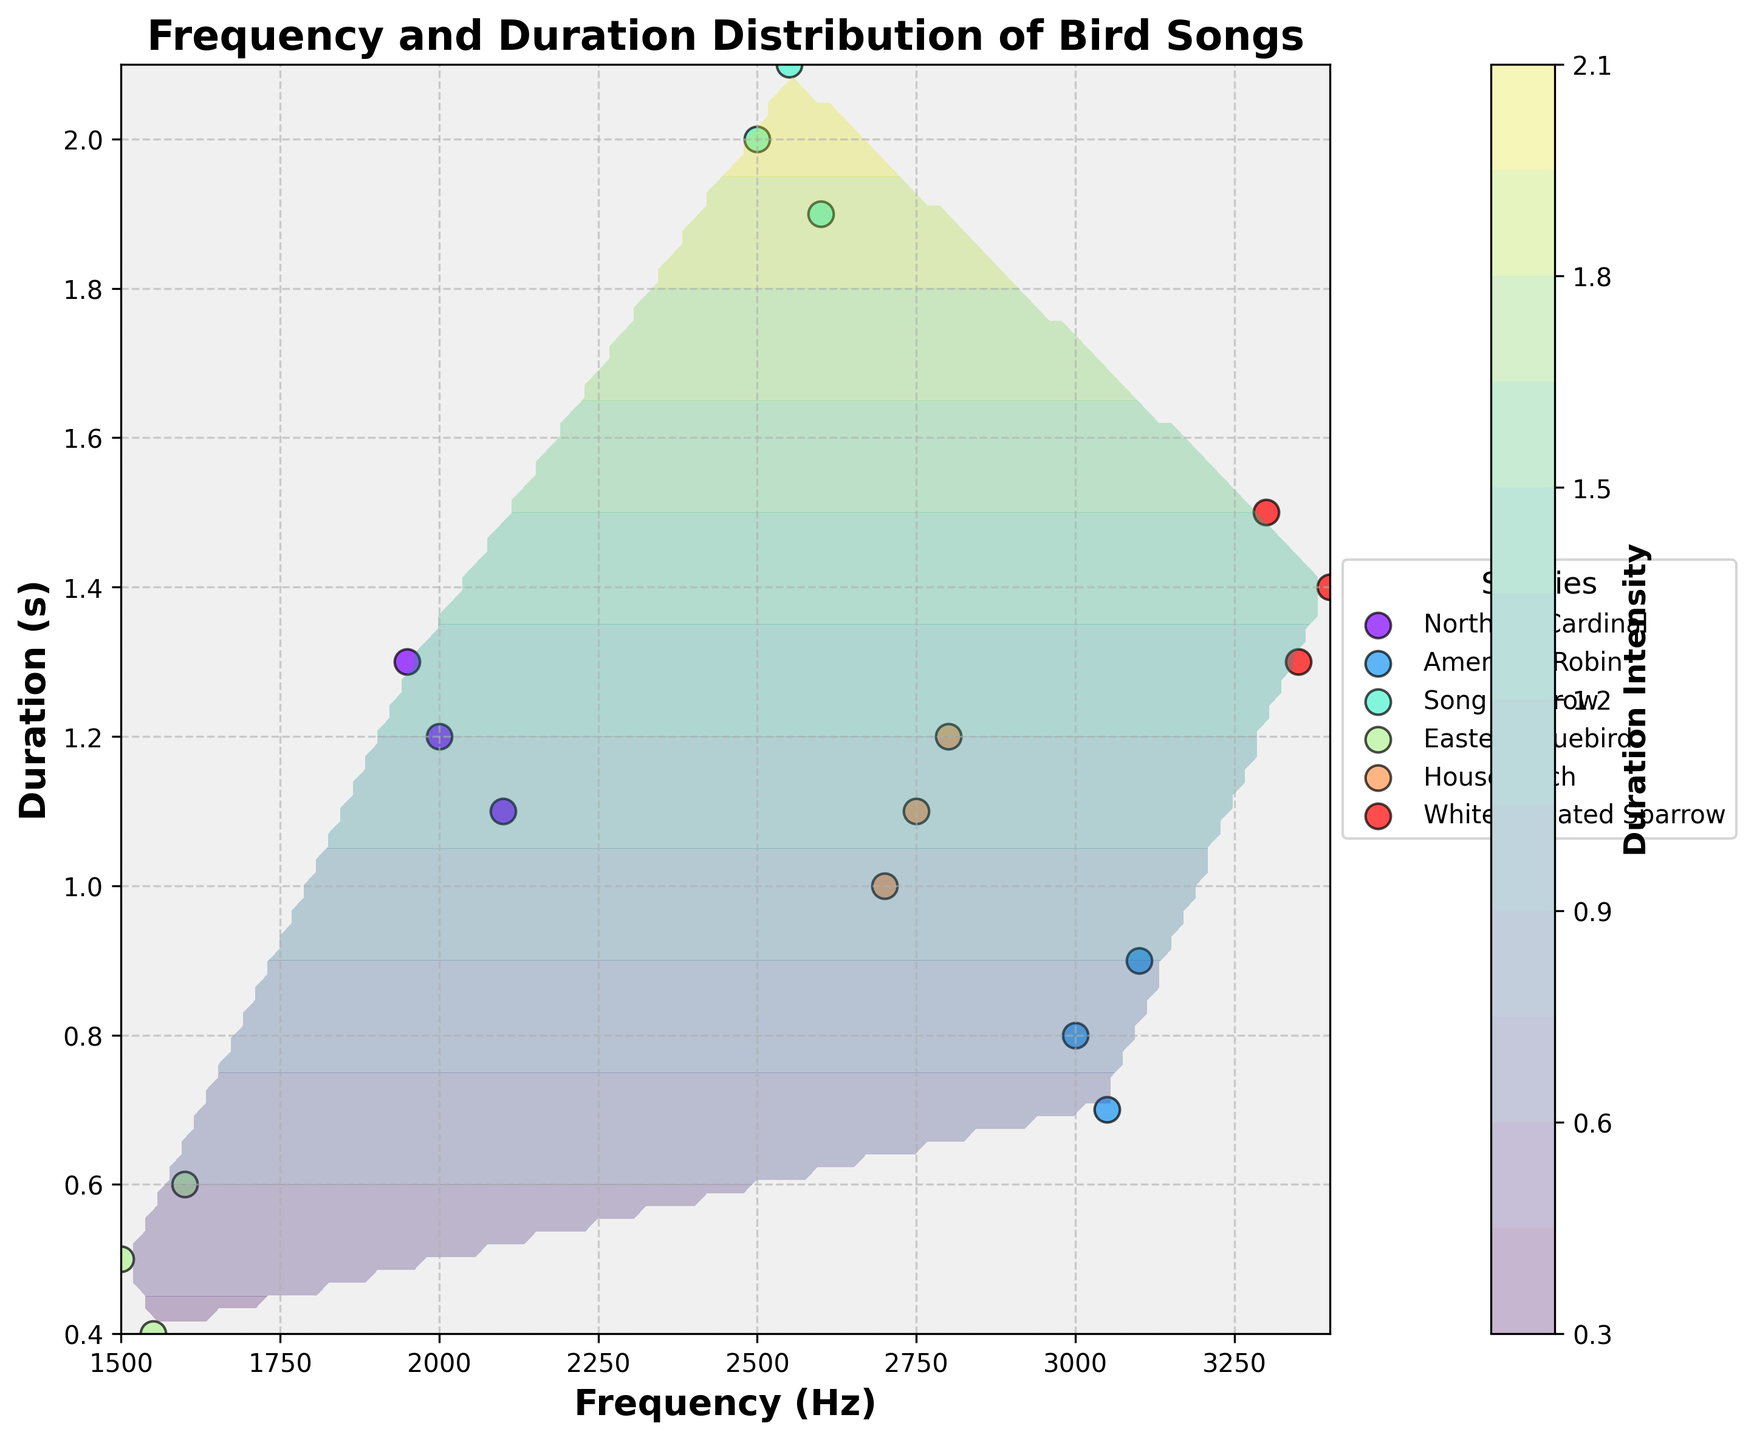How many different bird species are represented in the plot? Count the number of distinct species listed in the legend.
Answer: 6 What is the range of song durations for the Northern Cardinal? Identify the shortest and longest durations for the Northern Cardinal in the scatter plot.
Answer: 1.1 s to 1.3 s Which species has the highest frequency bird song? Find the species associated with the highest frequency value on the x-axis.
Answer: White-throated Sparrow How does the frequency range of the American Robin compare to that of the Eastern Bluebird? Compare the highest and lowest frequencies for the American Robin to those of the Eastern Bluebird by inspecting the scatter plot symbols.
Answer: American Robin: 3000-3100 Hz, Eastern Bluebird: 1500-1600 Hz What is the average duration of bird songs for the Song Sparrow? Identify the duration values for the Song Sparrow, sum them up and divide by the number of values. (2.0+1.9+2.1)/3 = 2.0
Answer: 2.0 s Which species has the broadest range in song frequency? Compare the frequency ranges for each species by noting the spread of their scatter points along the x-axis.
Answer: American Robin In the contour plot, which region exhibits the highest overall song duration intensity? Identify the area with the darkest shading in the contour plot, indicating maximum duration intensity.
Answer: Around 2.0 s and 2500 Hz Do any species have overlapping frequency ranges but noticeably different average durations? Check for bird species that share similar frequency values but differ significantly in average song duration by comparing scatter plots.
Answer: Song Sparrow and House Finch Based on the contour plot, is there a clear relationship between frequency and song duration across all species? Examine the overall trend in the contour plot and observe whether a linear or non-linear relationship exists between frequency and song duration.
Answer: No clear relationship What is the median frequency of the bird songs for the House Finch? Identify the frequency values for the House Finch, order them and find the middle value.
Answer: 2750 Hz 